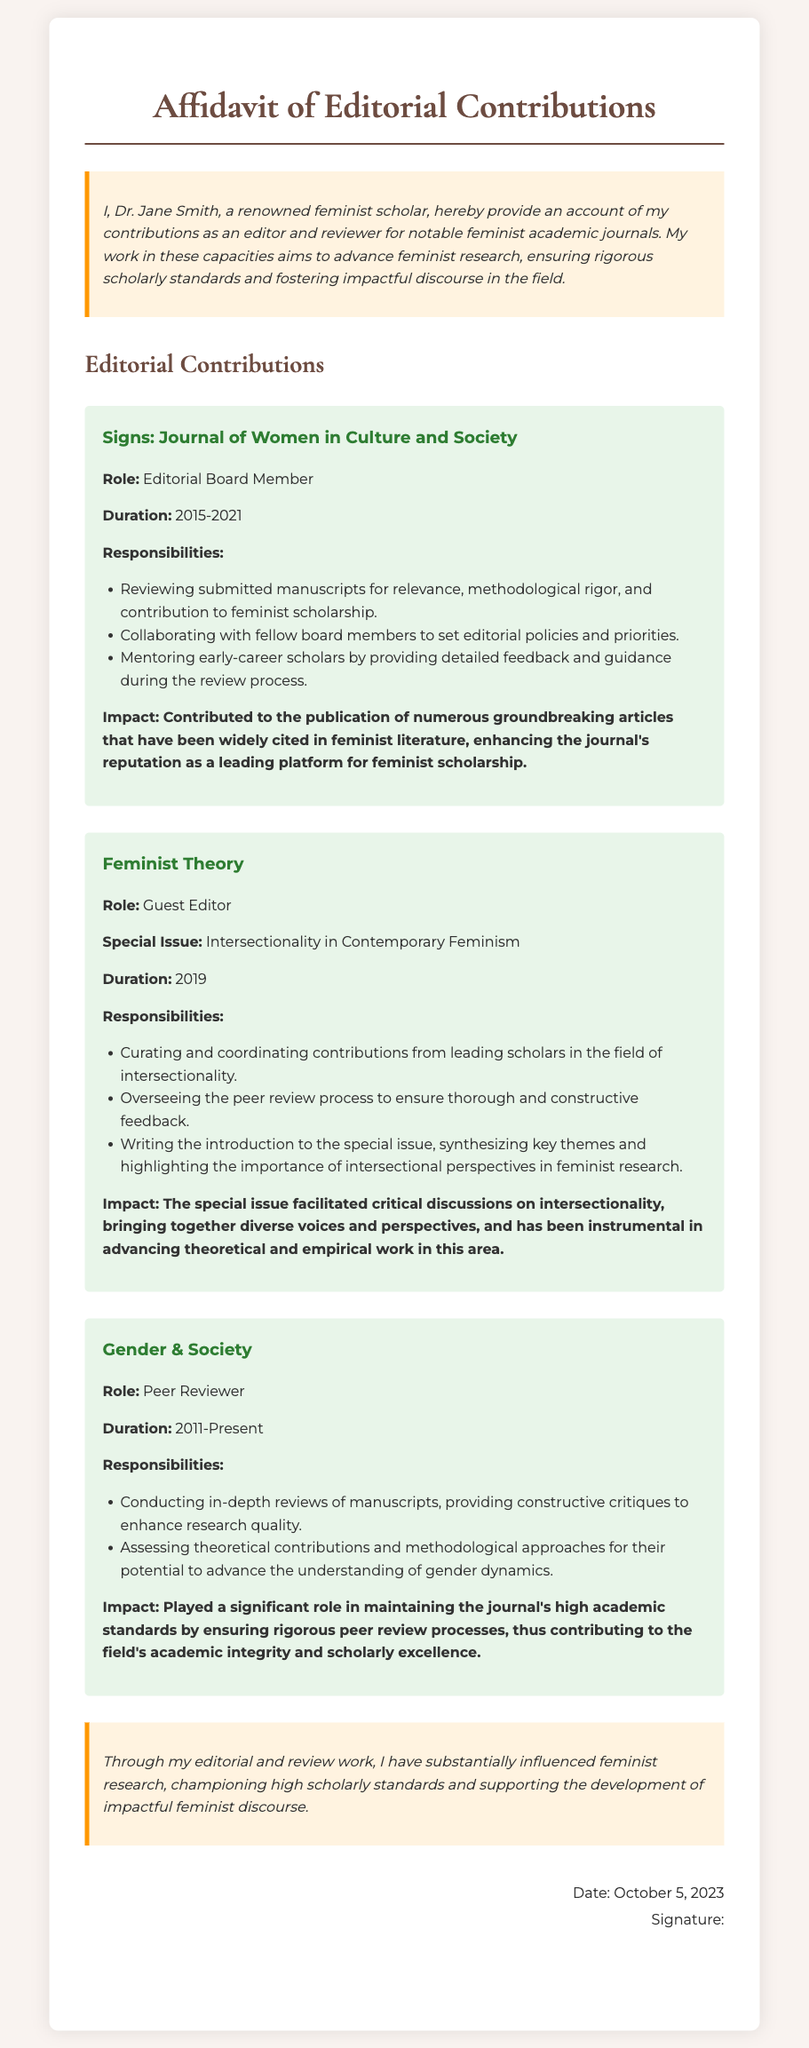what is the name of the scholar? The document is signed by Dr. Jane Smith, who is identified as the renowned feminist scholar.
Answer: Dr. Jane Smith which journal did Dr. Jane Smith serve as an Editorial Board Member? The journal where Dr. Jane Smith served as an Editorial Board Member is mentioned in the document's first entry.
Answer: Signs: Journal of Women in Culture and Society what are the years of Dr. Jane Smith's editorial role at Signs? The duration of her role at the journal is specified in the document.
Answer: 2015-2021 what was the special issue curated by Dr. Jane Smith in Feminist Theory? The document lists the special issue she curated and emphasizes its focus.
Answer: Intersectionality in Contemporary Feminism how long has Dr. Jane Smith been a Peer Reviewer for Gender & Society? The document indicates the duration of her role as a Peer Reviewer.
Answer: 2011-Present what is the primary focus of the special issue coordinated by Dr. Jane Smith? The document outlines the key theme of the special issue she oversaw.
Answer: Intersectionality what impact did Dr. Jane Smith have on Signs? The document describes her contributions and their significance to the journal's reputation.
Answer: Groundbreaking articles widely cited in feminist literature when was the affidavit signed? The date is clearly stated in the signature section of the document.
Answer: October 5, 2023 